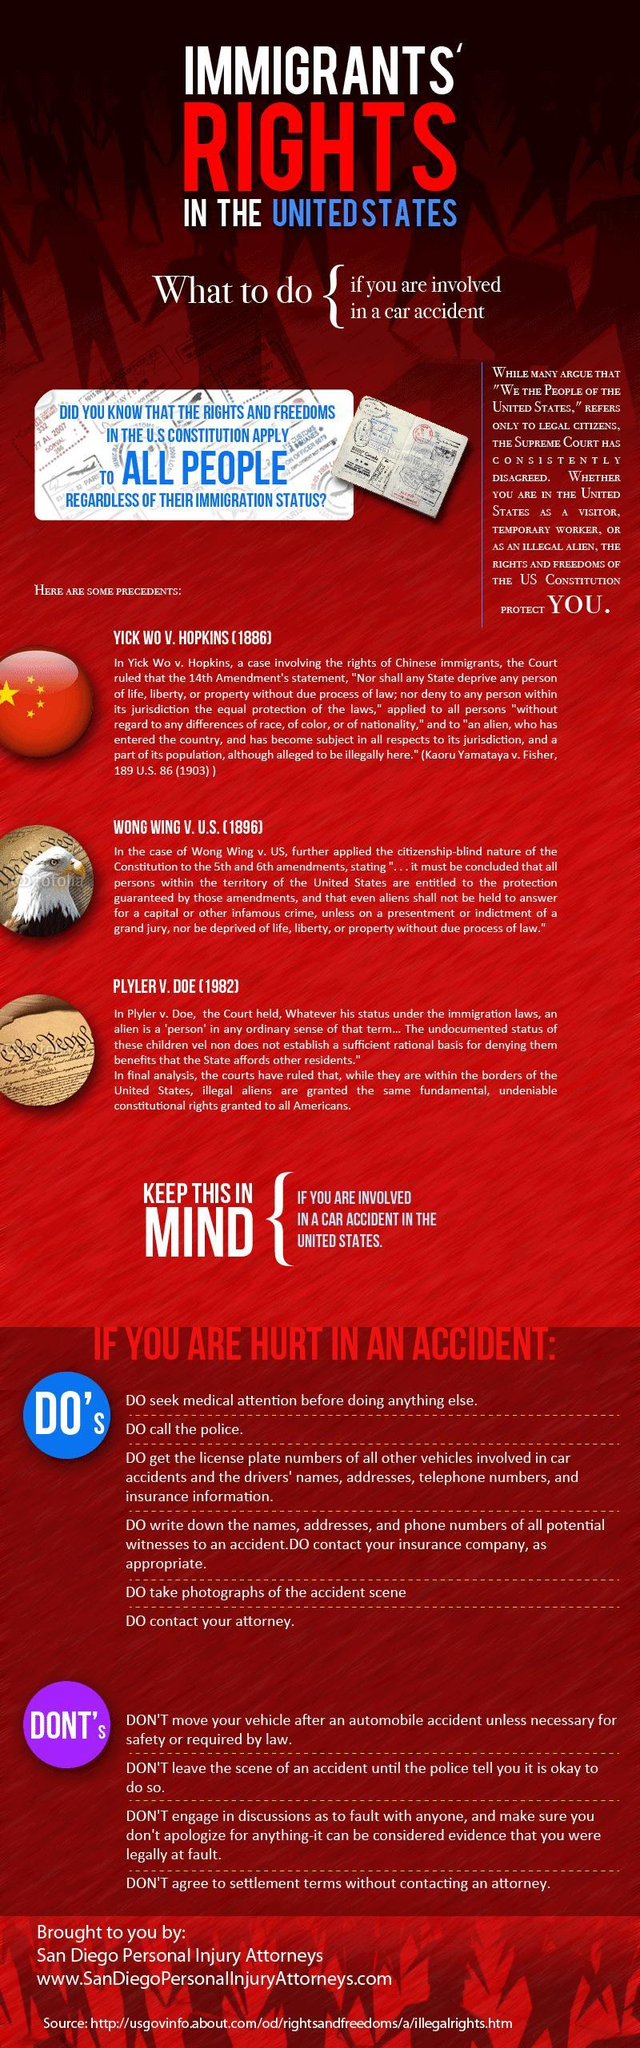How many precedents are listed?
Answer the question with a short phrase. 3 How many Do's are listed in the info graphic? 6 How many Don'ts are listed in the info graphic? 4 